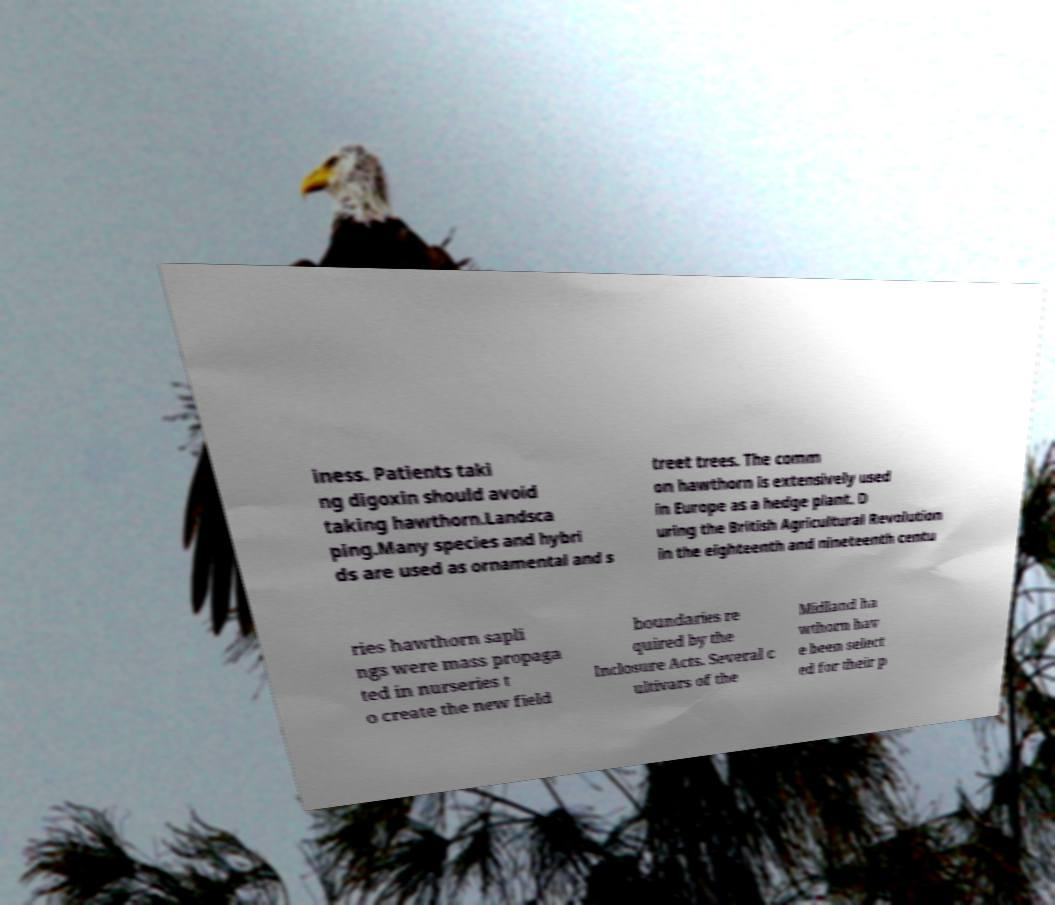There's text embedded in this image that I need extracted. Can you transcribe it verbatim? iness. Patients taki ng digoxin should avoid taking hawthorn.Landsca ping.Many species and hybri ds are used as ornamental and s treet trees. The comm on hawthorn is extensively used in Europe as a hedge plant. D uring the British Agricultural Revolution in the eighteenth and nineteenth centu ries hawthorn sapli ngs were mass propaga ted in nurseries t o create the new field boundaries re quired by the Inclosure Acts. Several c ultivars of the Midland ha wthorn hav e been select ed for their p 